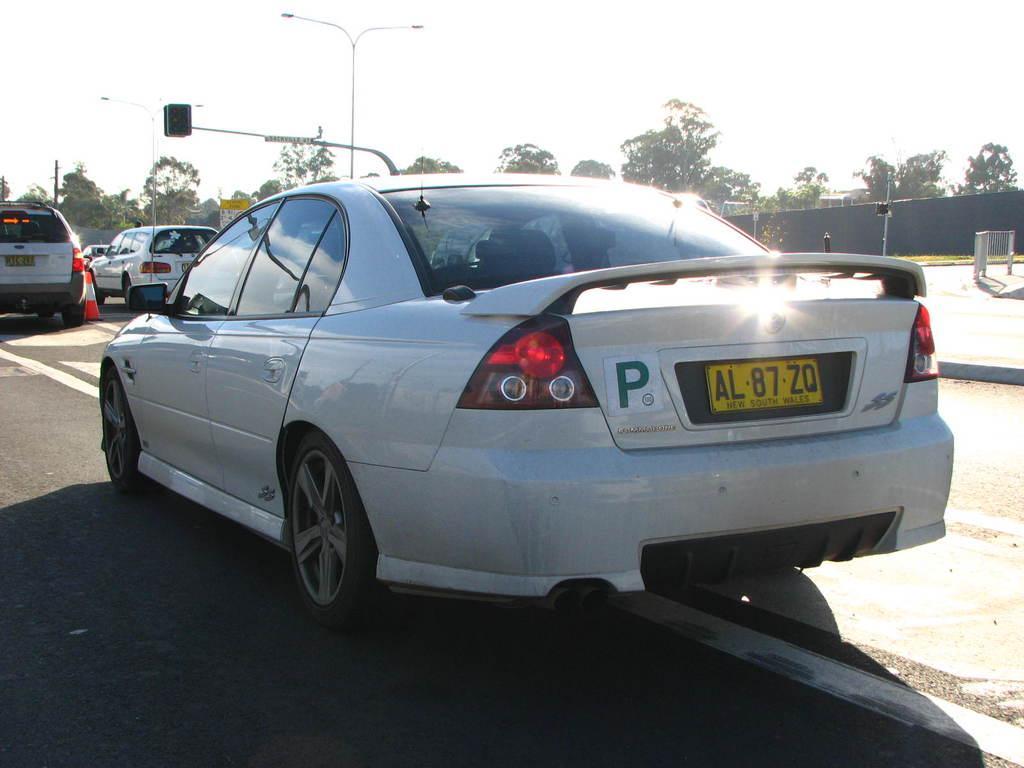Describe this image in one or two sentences. In this image, there are some cars on the road. There are some trees and poles in middle of the image. There is a sky at the top of the image. 